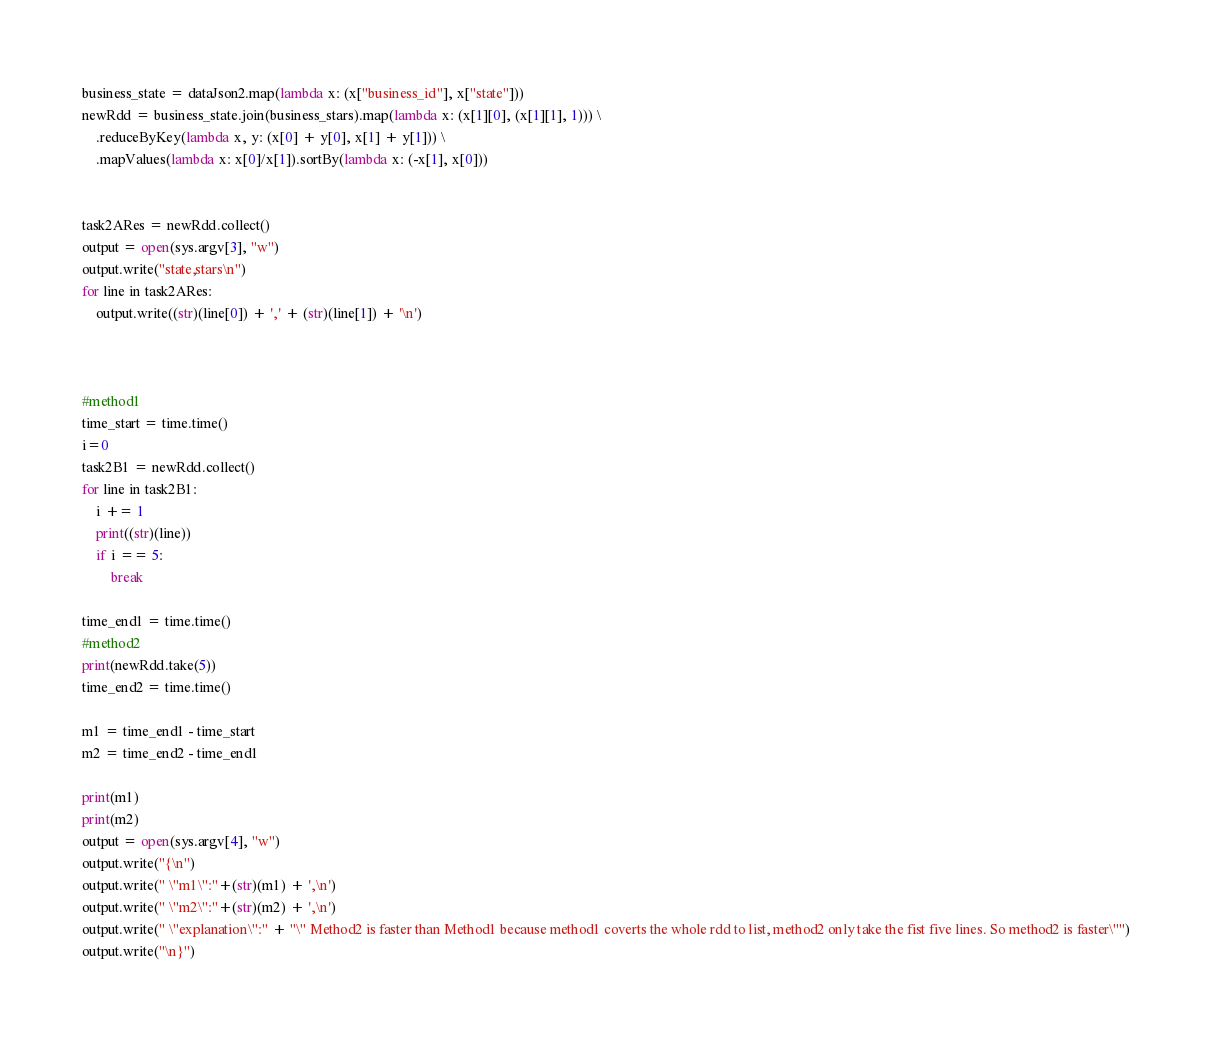<code> <loc_0><loc_0><loc_500><loc_500><_Python_>
business_state = dataJson2.map(lambda x: (x["business_id"], x["state"]))
newRdd = business_state.join(business_stars).map(lambda x: (x[1][0], (x[1][1], 1))) \
    .reduceByKey(lambda x, y: (x[0] + y[0], x[1] + y[1])) \
    .mapValues(lambda x: x[0]/x[1]).sortBy(lambda x: (-x[1], x[0]))


task2ARes = newRdd.collect()
output = open(sys.argv[3], "w")
output.write("state,stars\n")
for line in task2ARes:
    output.write((str)(line[0]) + ',' + (str)(line[1]) + '\n')



#method1
time_start = time.time()
i=0
task2B1 = newRdd.collect()
for line in task2B1:
    i += 1
    print((str)(line))
    if i == 5:
        break

time_end1 = time.time()
#method2
print(newRdd.take(5))
time_end2 = time.time()

m1 = time_end1 - time_start
m2 = time_end2 - time_end1

print(m1)
print(m2)
output = open(sys.argv[4], "w")
output.write("{\n")
output.write(" \"m1\":"+(str)(m1) + ',\n')
output.write(" \"m2\":"+(str)(m2) + ',\n')
output.write(" \"explanation\":" + "\" Method2 is faster than Method1 because method1 coverts the whole rdd to list, method2 only take the fist five lines. So method2 is faster\"")
output.write("\n}")




</code> 